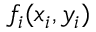<formula> <loc_0><loc_0><loc_500><loc_500>f _ { i } ( x _ { i } , y _ { i } )</formula> 